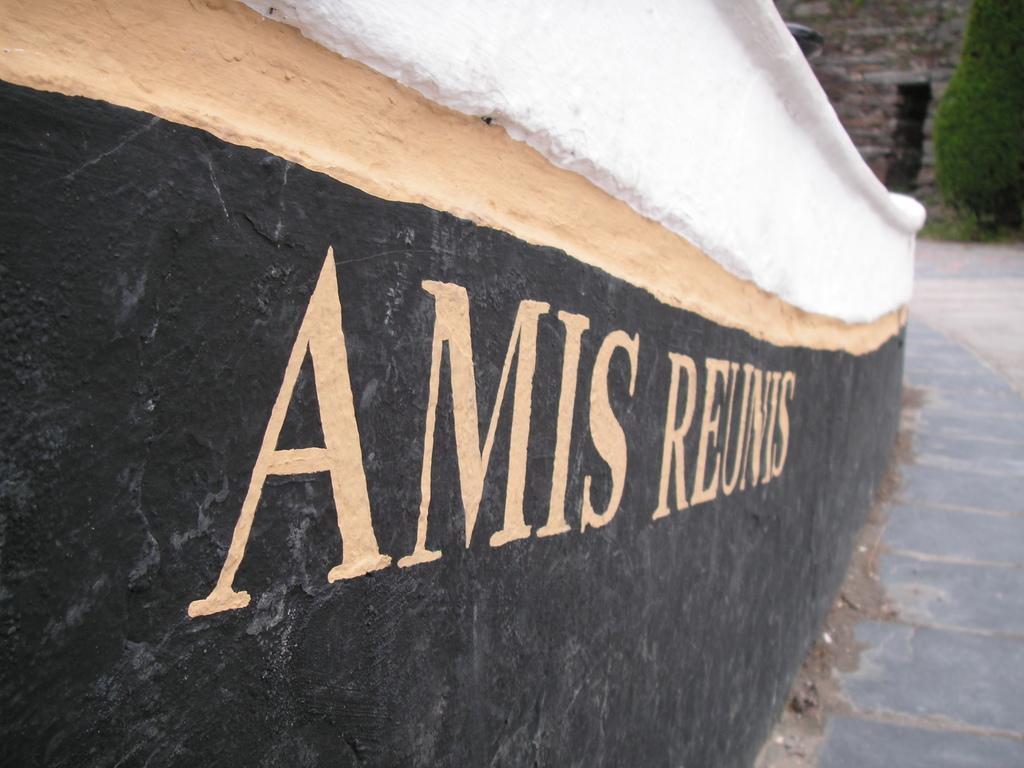Describe this image in one or two sentences. In this image we can see walls and floor. On the wall we can see something is written on it. In the background there is a tree. 